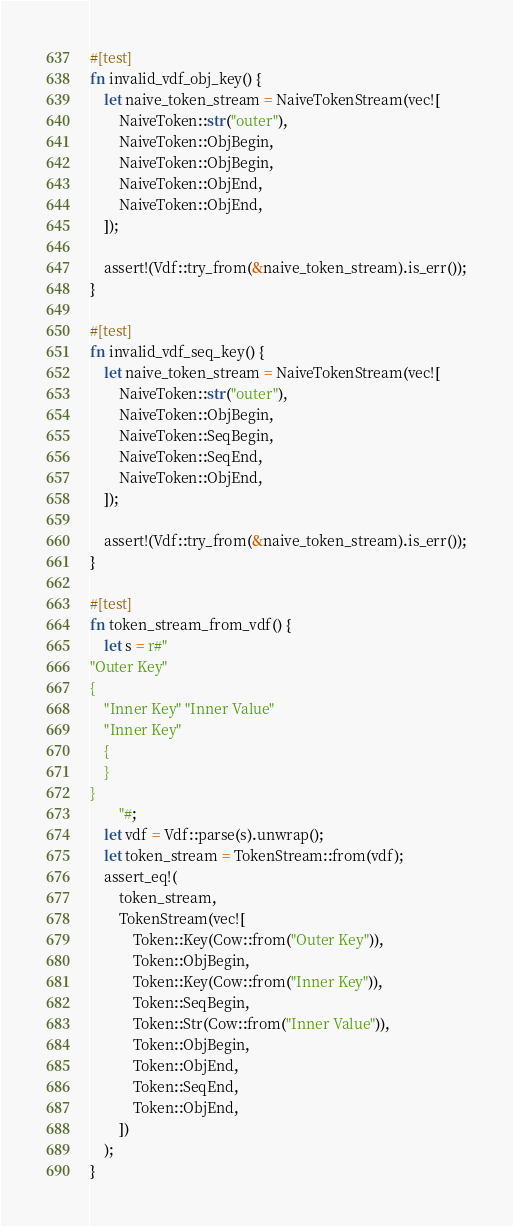<code> <loc_0><loc_0><loc_500><loc_500><_Rust_>
#[test]
fn invalid_vdf_obj_key() {
    let naive_token_stream = NaiveTokenStream(vec![
        NaiveToken::str("outer"),
        NaiveToken::ObjBegin,
        NaiveToken::ObjBegin,
        NaiveToken::ObjEnd,
        NaiveToken::ObjEnd,
    ]);

    assert!(Vdf::try_from(&naive_token_stream).is_err());
}

#[test]
fn invalid_vdf_seq_key() {
    let naive_token_stream = NaiveTokenStream(vec![
        NaiveToken::str("outer"),
        NaiveToken::ObjBegin,
        NaiveToken::SeqBegin,
        NaiveToken::SeqEnd,
        NaiveToken::ObjEnd,
    ]);

    assert!(Vdf::try_from(&naive_token_stream).is_err());
}

#[test]
fn token_stream_from_vdf() {
    let s = r#"
"Outer Key"
{
    "Inner Key" "Inner Value"
    "Inner Key"
    {
    }
}
        "#;
    let vdf = Vdf::parse(s).unwrap();
    let token_stream = TokenStream::from(vdf);
    assert_eq!(
        token_stream,
        TokenStream(vec![
            Token::Key(Cow::from("Outer Key")),
            Token::ObjBegin,
            Token::Key(Cow::from("Inner Key")),
            Token::SeqBegin,
            Token::Str(Cow::from("Inner Value")),
            Token::ObjBegin,
            Token::ObjEnd,
            Token::SeqEnd,
            Token::ObjEnd,
        ])
    );
}
</code> 